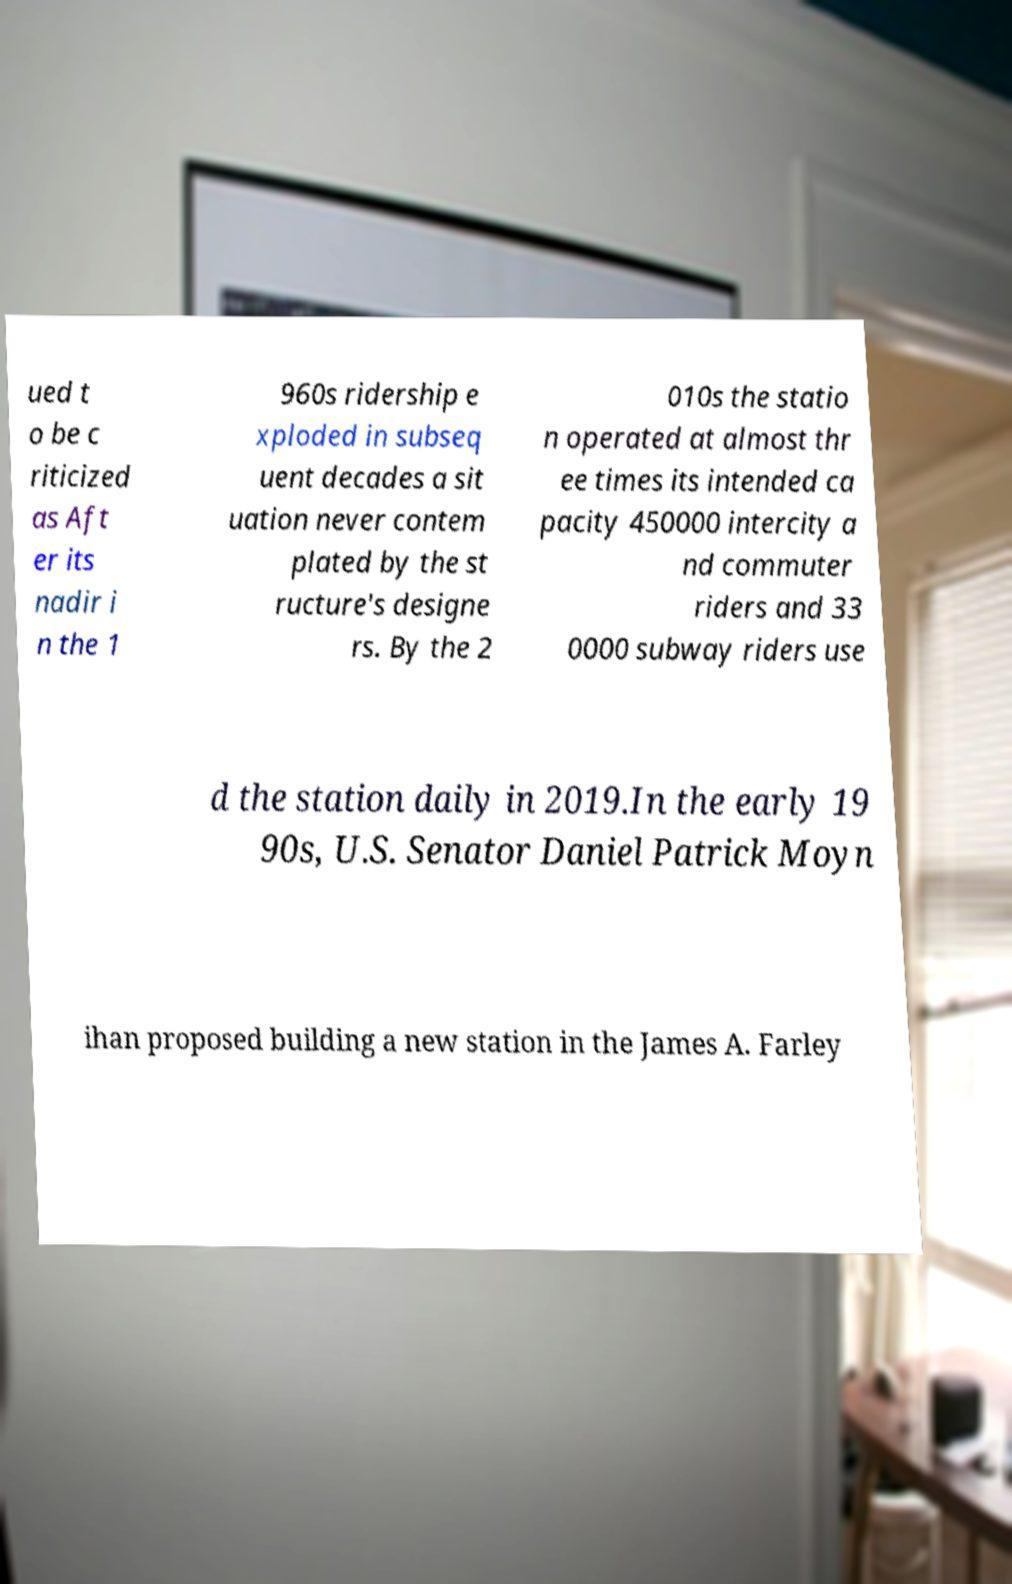What messages or text are displayed in this image? I need them in a readable, typed format. ued t o be c riticized as Aft er its nadir i n the 1 960s ridership e xploded in subseq uent decades a sit uation never contem plated by the st ructure's designe rs. By the 2 010s the statio n operated at almost thr ee times its intended ca pacity 450000 intercity a nd commuter riders and 33 0000 subway riders use d the station daily in 2019.In the early 19 90s, U.S. Senator Daniel Patrick Moyn ihan proposed building a new station in the James A. Farley 